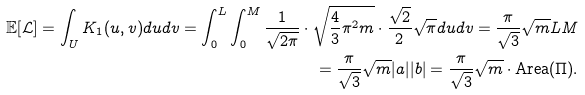<formula> <loc_0><loc_0><loc_500><loc_500>\mathbb { E } [ \mathcal { L } ] = \int _ { U } K _ { 1 } ( u , v ) d u d v = \int _ { 0 } ^ { L } \int _ { 0 } ^ { M } \frac { 1 } { \sqrt { 2 \pi } } \cdot \sqrt { \frac { 4 } { 3 } \pi ^ { 2 } m } \cdot \frac { \sqrt { 2 } } { 2 } \sqrt { \pi } d u d v = \frac { \pi } { \sqrt { 3 } } \sqrt { m } L M \\ = \frac { \pi } { \sqrt { 3 } } \sqrt { m } | a | | b | = \frac { \pi } { \sqrt { 3 } } \sqrt { m } \cdot \text {Area} ( \Pi ) .</formula> 